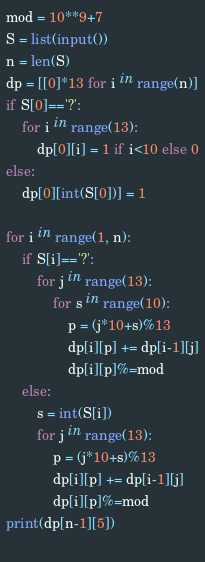Convert code to text. <code><loc_0><loc_0><loc_500><loc_500><_Python_>mod = 10**9+7
S = list(input())
n = len(S)
dp = [[0]*13 for i in range(n)]
if S[0]=='?':
    for i in range(13):
        dp[0][i] = 1 if i<10 else 0
else:
    dp[0][int(S[0])] = 1
    
for i in range(1, n):
    if S[i]=='?':
        for j in range(13):
            for s in range(10):
                p = (j*10+s)%13
                dp[i][p] += dp[i-1][j]
                dp[i][p]%=mod
    else:
        s = int(S[i])
        for j in range(13):
            p = (j*10+s)%13
            dp[i][p] += dp[i-1][j]
            dp[i][p]%=mod
print(dp[n-1][5])
    </code> 